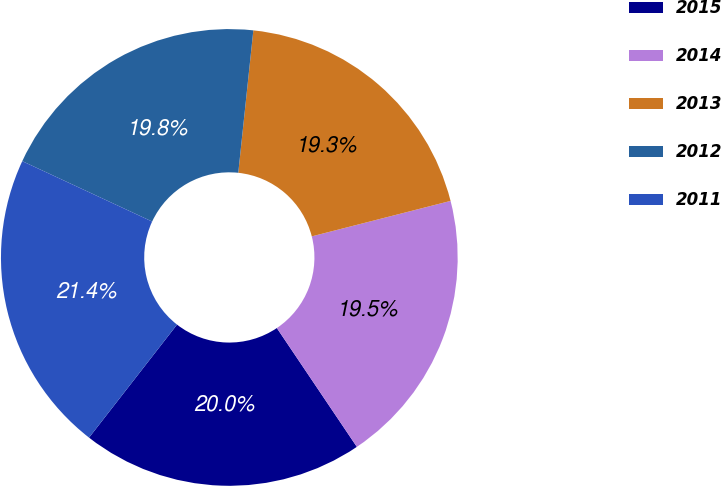Convert chart to OTSL. <chart><loc_0><loc_0><loc_500><loc_500><pie_chart><fcel>2015<fcel>2014<fcel>2013<fcel>2012<fcel>2011<nl><fcel>19.96%<fcel>19.55%<fcel>19.34%<fcel>19.75%<fcel>21.4%<nl></chart> 